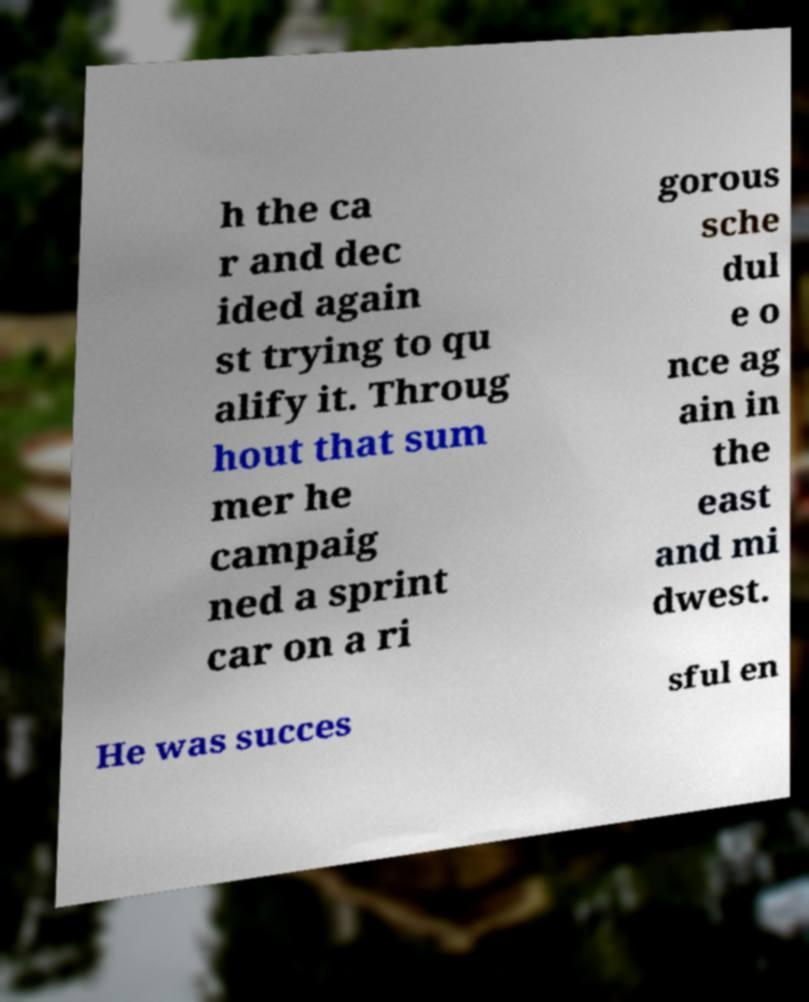Can you read and provide the text displayed in the image?This photo seems to have some interesting text. Can you extract and type it out for me? h the ca r and dec ided again st trying to qu alify it. Throug hout that sum mer he campaig ned a sprint car on a ri gorous sche dul e o nce ag ain in the east and mi dwest. He was succes sful en 